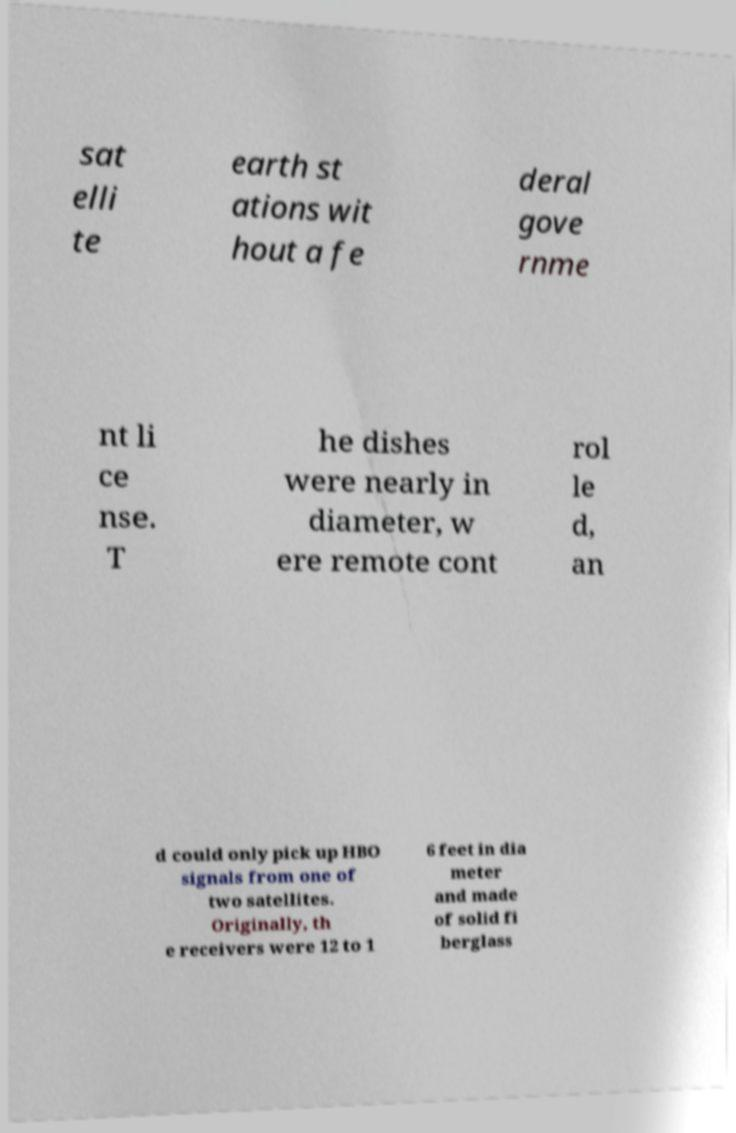Could you extract and type out the text from this image? sat elli te earth st ations wit hout a fe deral gove rnme nt li ce nse. T he dishes were nearly in diameter, w ere remote cont rol le d, an d could only pick up HBO signals from one of two satellites. Originally, th e receivers were 12 to 1 6 feet in dia meter and made of solid fi berglass 